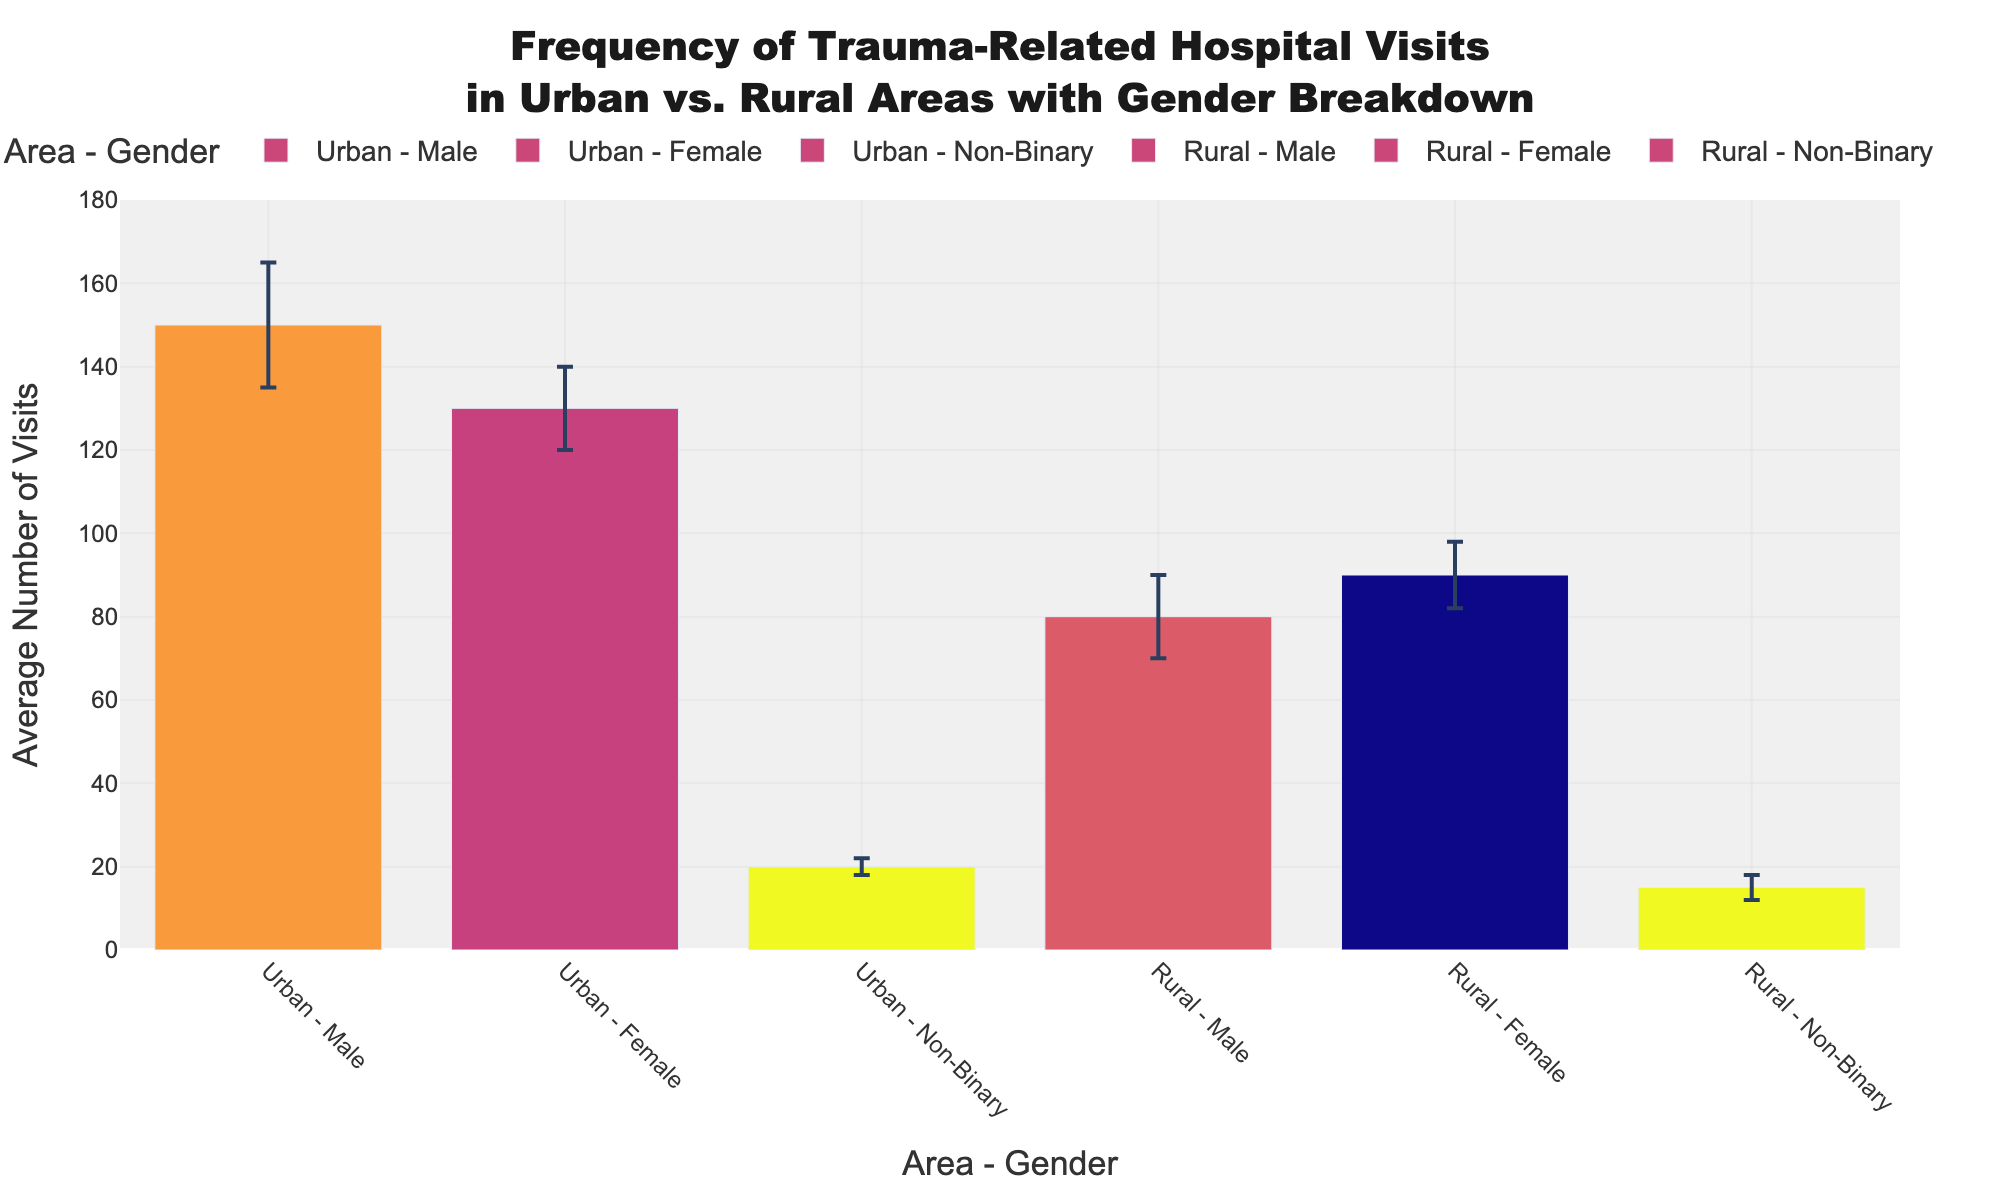What's the average number of trauma-related hospital visits for males in urban areas? By referring to the bar labeled "Urban - Male," we see that the average number of visits is stated directly as 150.
Answer: 150 Which gender has the least average trauma-related hospital visits in rural areas? By looking at the bars for the Rural category and comparing all genders, "Rural - Non-Binary" has the shortest bar, indicating the least visits which is 15.
Answer: Non-Binary What's the difference in the average number of visits between urban males and rural males? The average number of visits for urban males is 150 and for rural males is 80. The difference can be calculated as 150 - 80 = 70.
Answer: 70 Among females, which area has a higher average number of visits? By comparing the bars labeled "Urban - Female" and "Rural - Female," the urban bar is higher (130) compared to the rural bar (90).
Answer: Urban What is the maximum standard deviation reported in rural areas? By looking at the error bars in the Rural category, the male gender has the longest error bar, corresponding to a standard deviation of 10.
Answer: 10 Which gender in urban areas has the smallest standard deviation? By observing the length of the error bars in urban areas, the "Urban - Female" bar has the smallest error bar, meaning the standard deviation is 10.
Answer: Female What is the total average number of visits for non-binary individuals in both areas? The average for urban non-binary is 20 and for rural non-binary is 15. Adding these together gives 20 + 15 = 35.
Answer: 35 How do the average numbers of visits for females compare between urban and rural areas? "Urban - Female" has an average of 130 visits, while "Rural - Female" has an average of 90. Comparing these, 130 is greater than 90.
Answer: Urban has more visits For males, what is the ratio of urban to rural average visits? The average number of visits for urban males is 150 and for rural males is 80. The ratio is calculated as 150/80 = 1.875.
Answer: 1.875 Are the average visits for non-binary individuals similar in urban and rural areas? By comparing the two bars for non-binary individuals, urban has 20 visits, and rural has 15 visits. Given the small absolute difference, they are relatively similar.
Answer: Yes 